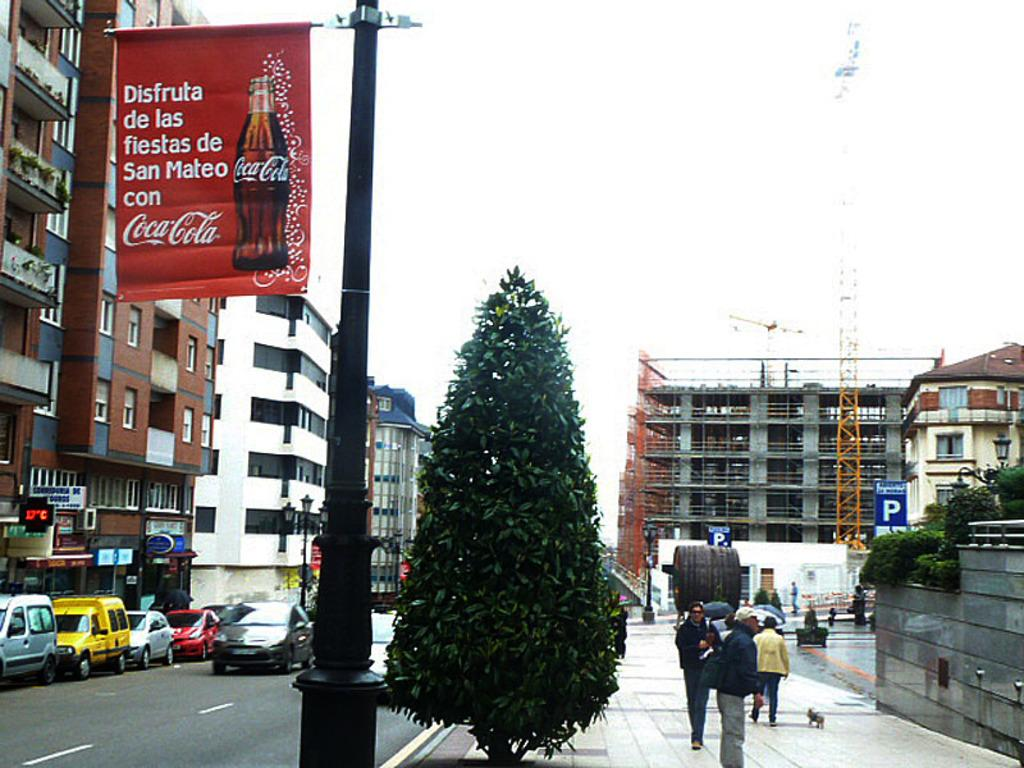<image>
Provide a brief description of the given image. Advertising for coca cola is shown on a light post. 